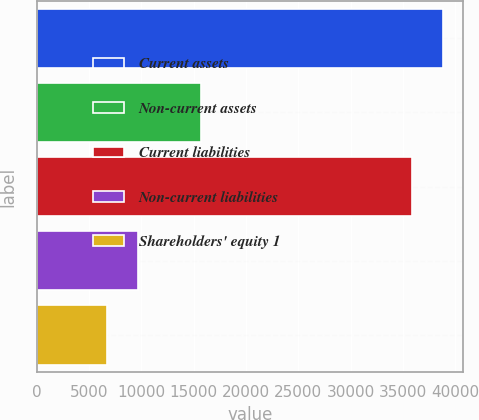Convert chart to OTSL. <chart><loc_0><loc_0><loc_500><loc_500><bar_chart><fcel>Current assets<fcel>Non-current assets<fcel>Current liabilities<fcel>Non-current liabilities<fcel>Shareholders' equity 1<nl><fcel>38835<fcel>15710<fcel>35857<fcel>9721<fcel>6743<nl></chart> 